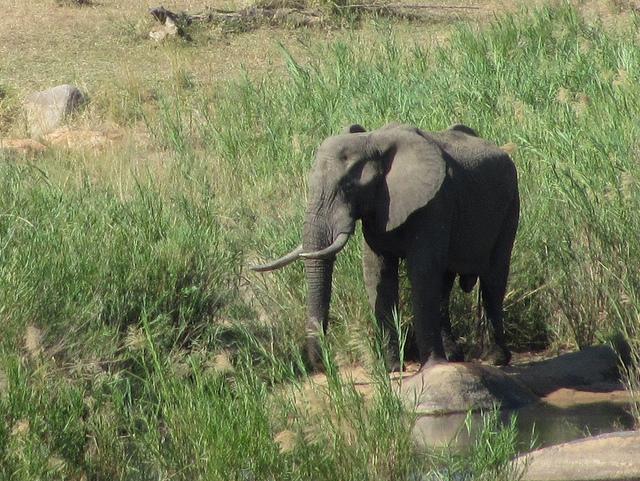Which is bigger for this animal, the tail or the nose?
Write a very short answer. Nose. Is the elephant crossing a field?
Short answer required. Yes. How long are the elephants' tusks?
Be succinct. 1 foot. What is the elephant doing?
Be succinct. Standing. What object is in front of the elephants?
Quick response, please. Rock. Is this a female?
Keep it brief. No. Is the grass green?
Short answer required. Yes. How many tusks are visible in the image?
Answer briefly. 2. 